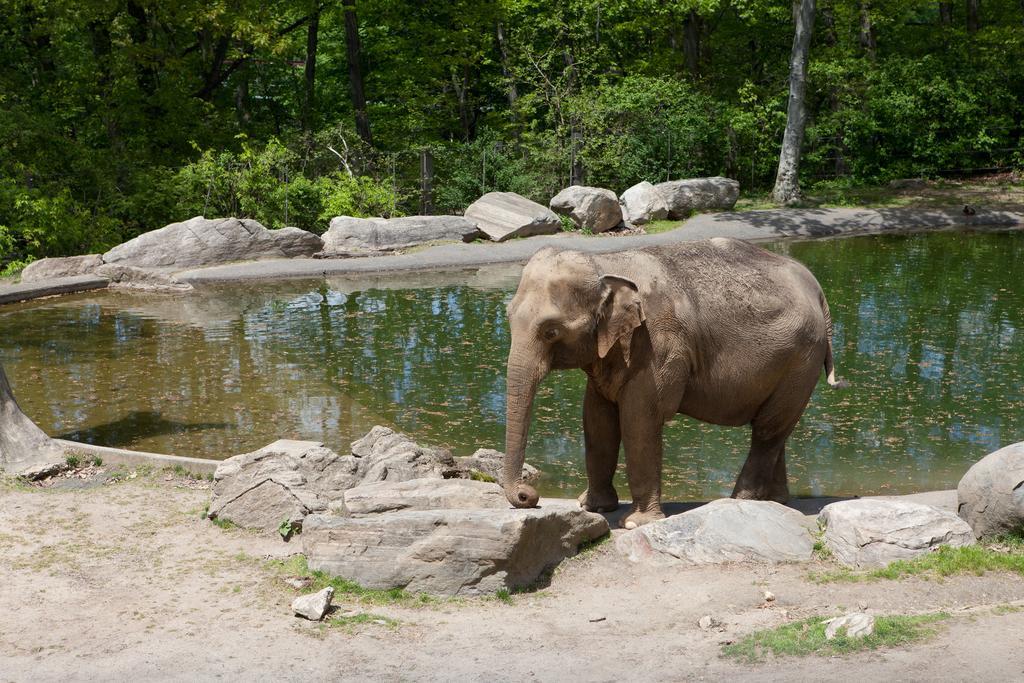Please provide a concise description of this image. In this image there are trees towards the top of the image, there is water, there are rocks, there is an elephant, there is grass, there are stones on the ground. 